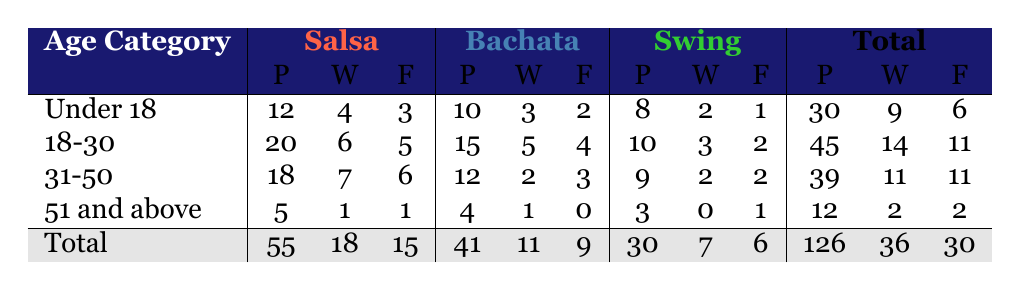What is the total number of participants in the Salsa dance style? To find the total number of participants in Salsa, we need to add the values from the "Participants" column under the Salsa category. There are 12 (Under 18) + 20 (18-30) + 18 (31-50) + 5 (51 and above) = 55 participants in total.
Answer: 55 How many winners are there in the Bachata dance style for the age category 31-50? Looking at the Bachata column for the age category 31-50, the number of winners is 2.
Answer: 2 What is the total number of finalists across all dance styles for participants aged 51 and above? To find the total number of finalists for age category 51 and above, we sum the number of finalists across all three dance styles: 1 (Salsa) + 0 (Bachata) + 1 (Swing) = 2 finalists in total.
Answer: 2 Which age category has the highest number of winners in total? To determine which age category has the highest number of winners, we add the number of winners for each age category: Under 18: 4 + 18-30: 6 + 31-50: 7 + 51 and above: 1. The totals are 4, 6, 7, and 1, respectively. The highest is 7 in the 31-50 category.
Answer: 31-50 Is the statement true or false: More participants compete in Swing than in Bachata among the Under 18 age category? In the Under 18 age category, there are 10 participants in Bachata and 8 participants in Swing. Since 10 is greater than 8, the statement is false.
Answer: False What is the average number of winners per dance style for the 18-30 age category? For the 18-30 age category, we have 6 winners in Salsa, 5 in Bachata, and 3 in Swing. Thus, the total winners are 6 + 5 + 3 = 14. There are 3 dance styles, so the average number of winners is 14/3 = approximately 4.67.
Answer: 4.67 How many more participants are there in the 18-30 age category compared to the 51 and above category? The number of participants in the 18-30 age category is 45, while in the 51 and above category, it is 12. To find the difference, subtract 12 from 45: 45 - 12 = 33.
Answer: 33 What percentage of participants in the Under 18 age category are winners? There are 12 participants in the Under 18 age category and 4 of them are winners. To calculate the percentage, divide the number of winners (4) by the total participants (12) and then multiply by 100: (4/12) * 100 = 33.33%.
Answer: 33.33% Which dance style has the lowest number of finalists altogether? To find the dance style with the lowest number of finalists, we add the finalists across styles: Salsa: 15, Bachata: 9, Swing: 6. Since Swing has the lowest total of 6 finalists, it is the answer.
Answer: Swing 